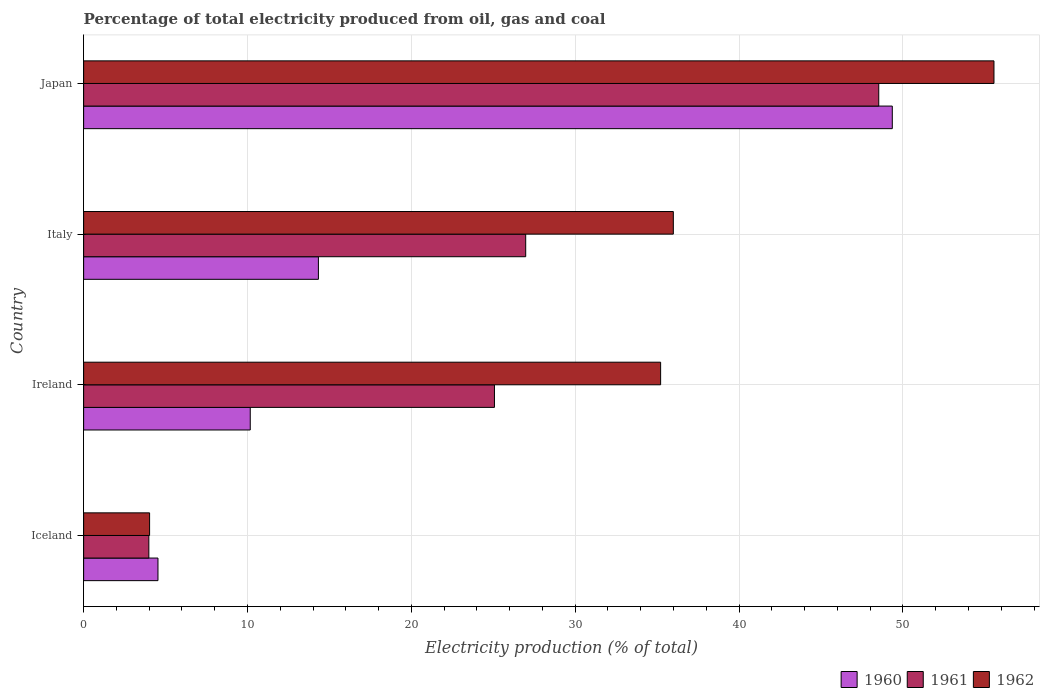How many groups of bars are there?
Make the answer very short. 4. Are the number of bars per tick equal to the number of legend labels?
Make the answer very short. Yes. How many bars are there on the 3rd tick from the bottom?
Offer a very short reply. 3. What is the label of the 2nd group of bars from the top?
Keep it short and to the point. Italy. What is the electricity production in in 1960 in Italy?
Your response must be concise. 14.33. Across all countries, what is the maximum electricity production in in 1962?
Offer a very short reply. 55.56. Across all countries, what is the minimum electricity production in in 1960?
Ensure brevity in your answer.  4.54. What is the total electricity production in in 1960 in the graph?
Your answer should be compact. 78.38. What is the difference between the electricity production in in 1961 in Iceland and that in Italy?
Provide a succinct answer. -23. What is the difference between the electricity production in in 1961 in Japan and the electricity production in in 1960 in Iceland?
Your answer should be compact. 43.99. What is the average electricity production in in 1962 per country?
Your response must be concise. 32.7. What is the difference between the electricity production in in 1962 and electricity production in in 1961 in Italy?
Provide a succinct answer. 9.01. What is the ratio of the electricity production in in 1962 in Ireland to that in Japan?
Your answer should be compact. 0.63. What is the difference between the highest and the second highest electricity production in in 1961?
Provide a short and direct response. 21.55. What is the difference between the highest and the lowest electricity production in in 1961?
Give a very brief answer. 44.54. In how many countries, is the electricity production in in 1961 greater than the average electricity production in in 1961 taken over all countries?
Offer a very short reply. 2. What does the 2nd bar from the bottom in Ireland represents?
Your answer should be very brief. 1961. How many bars are there?
Your answer should be compact. 12. How many countries are there in the graph?
Provide a succinct answer. 4. What is the difference between two consecutive major ticks on the X-axis?
Offer a terse response. 10. Are the values on the major ticks of X-axis written in scientific E-notation?
Your answer should be compact. No. How are the legend labels stacked?
Provide a succinct answer. Horizontal. What is the title of the graph?
Ensure brevity in your answer.  Percentage of total electricity produced from oil, gas and coal. What is the label or title of the X-axis?
Provide a succinct answer. Electricity production (% of total). What is the label or title of the Y-axis?
Your answer should be very brief. Country. What is the Electricity production (% of total) in 1960 in Iceland?
Provide a succinct answer. 4.54. What is the Electricity production (% of total) of 1961 in Iceland?
Offer a very short reply. 3.98. What is the Electricity production (% of total) of 1962 in Iceland?
Provide a succinct answer. 4.03. What is the Electricity production (% of total) of 1960 in Ireland?
Offer a very short reply. 10.17. What is the Electricity production (% of total) of 1961 in Ireland?
Your answer should be very brief. 25.07. What is the Electricity production (% of total) of 1962 in Ireland?
Keep it short and to the point. 35.21. What is the Electricity production (% of total) in 1960 in Italy?
Your response must be concise. 14.33. What is the Electricity production (% of total) in 1961 in Italy?
Keep it short and to the point. 26.98. What is the Electricity production (% of total) in 1962 in Italy?
Ensure brevity in your answer.  35.99. What is the Electricity production (% of total) of 1960 in Japan?
Offer a very short reply. 49.35. What is the Electricity production (% of total) in 1961 in Japan?
Ensure brevity in your answer.  48.52. What is the Electricity production (% of total) in 1962 in Japan?
Provide a succinct answer. 55.56. Across all countries, what is the maximum Electricity production (% of total) in 1960?
Your answer should be very brief. 49.35. Across all countries, what is the maximum Electricity production (% of total) in 1961?
Ensure brevity in your answer.  48.52. Across all countries, what is the maximum Electricity production (% of total) in 1962?
Your answer should be very brief. 55.56. Across all countries, what is the minimum Electricity production (% of total) in 1960?
Offer a terse response. 4.54. Across all countries, what is the minimum Electricity production (% of total) in 1961?
Your response must be concise. 3.98. Across all countries, what is the minimum Electricity production (% of total) in 1962?
Ensure brevity in your answer.  4.03. What is the total Electricity production (% of total) in 1960 in the graph?
Offer a terse response. 78.38. What is the total Electricity production (% of total) of 1961 in the graph?
Offer a terse response. 104.55. What is the total Electricity production (% of total) of 1962 in the graph?
Offer a terse response. 130.78. What is the difference between the Electricity production (% of total) in 1960 in Iceland and that in Ireland?
Ensure brevity in your answer.  -5.63. What is the difference between the Electricity production (% of total) in 1961 in Iceland and that in Ireland?
Make the answer very short. -21.09. What is the difference between the Electricity production (% of total) in 1962 in Iceland and that in Ireland?
Your answer should be compact. -31.19. What is the difference between the Electricity production (% of total) of 1960 in Iceland and that in Italy?
Keep it short and to the point. -9.79. What is the difference between the Electricity production (% of total) in 1961 in Iceland and that in Italy?
Ensure brevity in your answer.  -23. What is the difference between the Electricity production (% of total) in 1962 in Iceland and that in Italy?
Keep it short and to the point. -31.96. What is the difference between the Electricity production (% of total) in 1960 in Iceland and that in Japan?
Make the answer very short. -44.81. What is the difference between the Electricity production (% of total) of 1961 in Iceland and that in Japan?
Provide a short and direct response. -44.54. What is the difference between the Electricity production (% of total) of 1962 in Iceland and that in Japan?
Ensure brevity in your answer.  -51.53. What is the difference between the Electricity production (% of total) of 1960 in Ireland and that in Italy?
Ensure brevity in your answer.  -4.16. What is the difference between the Electricity production (% of total) in 1961 in Ireland and that in Italy?
Make the answer very short. -1.91. What is the difference between the Electricity production (% of total) of 1962 in Ireland and that in Italy?
Offer a very short reply. -0.78. What is the difference between the Electricity production (% of total) in 1960 in Ireland and that in Japan?
Make the answer very short. -39.18. What is the difference between the Electricity production (% of total) in 1961 in Ireland and that in Japan?
Ensure brevity in your answer.  -23.45. What is the difference between the Electricity production (% of total) in 1962 in Ireland and that in Japan?
Offer a terse response. -20.34. What is the difference between the Electricity production (% of total) in 1960 in Italy and that in Japan?
Keep it short and to the point. -35.02. What is the difference between the Electricity production (% of total) in 1961 in Italy and that in Japan?
Give a very brief answer. -21.55. What is the difference between the Electricity production (% of total) in 1962 in Italy and that in Japan?
Offer a very short reply. -19.57. What is the difference between the Electricity production (% of total) of 1960 in Iceland and the Electricity production (% of total) of 1961 in Ireland?
Your answer should be compact. -20.53. What is the difference between the Electricity production (% of total) in 1960 in Iceland and the Electricity production (% of total) in 1962 in Ireland?
Your response must be concise. -30.67. What is the difference between the Electricity production (% of total) in 1961 in Iceland and the Electricity production (% of total) in 1962 in Ireland?
Your response must be concise. -31.23. What is the difference between the Electricity production (% of total) of 1960 in Iceland and the Electricity production (% of total) of 1961 in Italy?
Your answer should be compact. -22.44. What is the difference between the Electricity production (% of total) of 1960 in Iceland and the Electricity production (% of total) of 1962 in Italy?
Your answer should be compact. -31.45. What is the difference between the Electricity production (% of total) in 1961 in Iceland and the Electricity production (% of total) in 1962 in Italy?
Your answer should be very brief. -32.01. What is the difference between the Electricity production (% of total) in 1960 in Iceland and the Electricity production (% of total) in 1961 in Japan?
Provide a succinct answer. -43.99. What is the difference between the Electricity production (% of total) in 1960 in Iceland and the Electricity production (% of total) in 1962 in Japan?
Your response must be concise. -51.02. What is the difference between the Electricity production (% of total) of 1961 in Iceland and the Electricity production (% of total) of 1962 in Japan?
Your response must be concise. -51.58. What is the difference between the Electricity production (% of total) of 1960 in Ireland and the Electricity production (% of total) of 1961 in Italy?
Ensure brevity in your answer.  -16.81. What is the difference between the Electricity production (% of total) of 1960 in Ireland and the Electricity production (% of total) of 1962 in Italy?
Your response must be concise. -25.82. What is the difference between the Electricity production (% of total) in 1961 in Ireland and the Electricity production (% of total) in 1962 in Italy?
Keep it short and to the point. -10.92. What is the difference between the Electricity production (% of total) in 1960 in Ireland and the Electricity production (% of total) in 1961 in Japan?
Offer a terse response. -38.36. What is the difference between the Electricity production (% of total) in 1960 in Ireland and the Electricity production (% of total) in 1962 in Japan?
Keep it short and to the point. -45.39. What is the difference between the Electricity production (% of total) in 1961 in Ireland and the Electricity production (% of total) in 1962 in Japan?
Offer a terse response. -30.48. What is the difference between the Electricity production (% of total) in 1960 in Italy and the Electricity production (% of total) in 1961 in Japan?
Your response must be concise. -34.2. What is the difference between the Electricity production (% of total) in 1960 in Italy and the Electricity production (% of total) in 1962 in Japan?
Offer a very short reply. -41.23. What is the difference between the Electricity production (% of total) of 1961 in Italy and the Electricity production (% of total) of 1962 in Japan?
Your answer should be very brief. -28.58. What is the average Electricity production (% of total) of 1960 per country?
Ensure brevity in your answer.  19.6. What is the average Electricity production (% of total) of 1961 per country?
Keep it short and to the point. 26.14. What is the average Electricity production (% of total) in 1962 per country?
Your answer should be compact. 32.7. What is the difference between the Electricity production (% of total) in 1960 and Electricity production (% of total) in 1961 in Iceland?
Ensure brevity in your answer.  0.56. What is the difference between the Electricity production (% of total) of 1960 and Electricity production (% of total) of 1962 in Iceland?
Make the answer very short. 0.51. What is the difference between the Electricity production (% of total) in 1961 and Electricity production (% of total) in 1962 in Iceland?
Keep it short and to the point. -0.05. What is the difference between the Electricity production (% of total) of 1960 and Electricity production (% of total) of 1961 in Ireland?
Offer a very short reply. -14.9. What is the difference between the Electricity production (% of total) of 1960 and Electricity production (% of total) of 1962 in Ireland?
Keep it short and to the point. -25.04. What is the difference between the Electricity production (% of total) of 1961 and Electricity production (% of total) of 1962 in Ireland?
Your answer should be very brief. -10.14. What is the difference between the Electricity production (% of total) in 1960 and Electricity production (% of total) in 1961 in Italy?
Your response must be concise. -12.65. What is the difference between the Electricity production (% of total) of 1960 and Electricity production (% of total) of 1962 in Italy?
Your answer should be compact. -21.66. What is the difference between the Electricity production (% of total) in 1961 and Electricity production (% of total) in 1962 in Italy?
Keep it short and to the point. -9.01. What is the difference between the Electricity production (% of total) in 1960 and Electricity production (% of total) in 1961 in Japan?
Provide a succinct answer. 0.83. What is the difference between the Electricity production (% of total) in 1960 and Electricity production (% of total) in 1962 in Japan?
Give a very brief answer. -6.2. What is the difference between the Electricity production (% of total) of 1961 and Electricity production (% of total) of 1962 in Japan?
Your response must be concise. -7.03. What is the ratio of the Electricity production (% of total) of 1960 in Iceland to that in Ireland?
Your answer should be very brief. 0.45. What is the ratio of the Electricity production (% of total) in 1961 in Iceland to that in Ireland?
Your response must be concise. 0.16. What is the ratio of the Electricity production (% of total) of 1962 in Iceland to that in Ireland?
Your answer should be very brief. 0.11. What is the ratio of the Electricity production (% of total) in 1960 in Iceland to that in Italy?
Provide a short and direct response. 0.32. What is the ratio of the Electricity production (% of total) of 1961 in Iceland to that in Italy?
Provide a succinct answer. 0.15. What is the ratio of the Electricity production (% of total) in 1962 in Iceland to that in Italy?
Ensure brevity in your answer.  0.11. What is the ratio of the Electricity production (% of total) in 1960 in Iceland to that in Japan?
Ensure brevity in your answer.  0.09. What is the ratio of the Electricity production (% of total) of 1961 in Iceland to that in Japan?
Provide a succinct answer. 0.08. What is the ratio of the Electricity production (% of total) in 1962 in Iceland to that in Japan?
Offer a very short reply. 0.07. What is the ratio of the Electricity production (% of total) of 1960 in Ireland to that in Italy?
Provide a succinct answer. 0.71. What is the ratio of the Electricity production (% of total) of 1961 in Ireland to that in Italy?
Ensure brevity in your answer.  0.93. What is the ratio of the Electricity production (% of total) in 1962 in Ireland to that in Italy?
Give a very brief answer. 0.98. What is the ratio of the Electricity production (% of total) in 1960 in Ireland to that in Japan?
Provide a short and direct response. 0.21. What is the ratio of the Electricity production (% of total) of 1961 in Ireland to that in Japan?
Provide a succinct answer. 0.52. What is the ratio of the Electricity production (% of total) in 1962 in Ireland to that in Japan?
Offer a terse response. 0.63. What is the ratio of the Electricity production (% of total) of 1960 in Italy to that in Japan?
Your response must be concise. 0.29. What is the ratio of the Electricity production (% of total) in 1961 in Italy to that in Japan?
Your answer should be very brief. 0.56. What is the ratio of the Electricity production (% of total) of 1962 in Italy to that in Japan?
Your response must be concise. 0.65. What is the difference between the highest and the second highest Electricity production (% of total) of 1960?
Provide a short and direct response. 35.02. What is the difference between the highest and the second highest Electricity production (% of total) of 1961?
Make the answer very short. 21.55. What is the difference between the highest and the second highest Electricity production (% of total) of 1962?
Your answer should be very brief. 19.57. What is the difference between the highest and the lowest Electricity production (% of total) in 1960?
Your answer should be compact. 44.81. What is the difference between the highest and the lowest Electricity production (% of total) in 1961?
Your answer should be very brief. 44.54. What is the difference between the highest and the lowest Electricity production (% of total) in 1962?
Offer a very short reply. 51.53. 